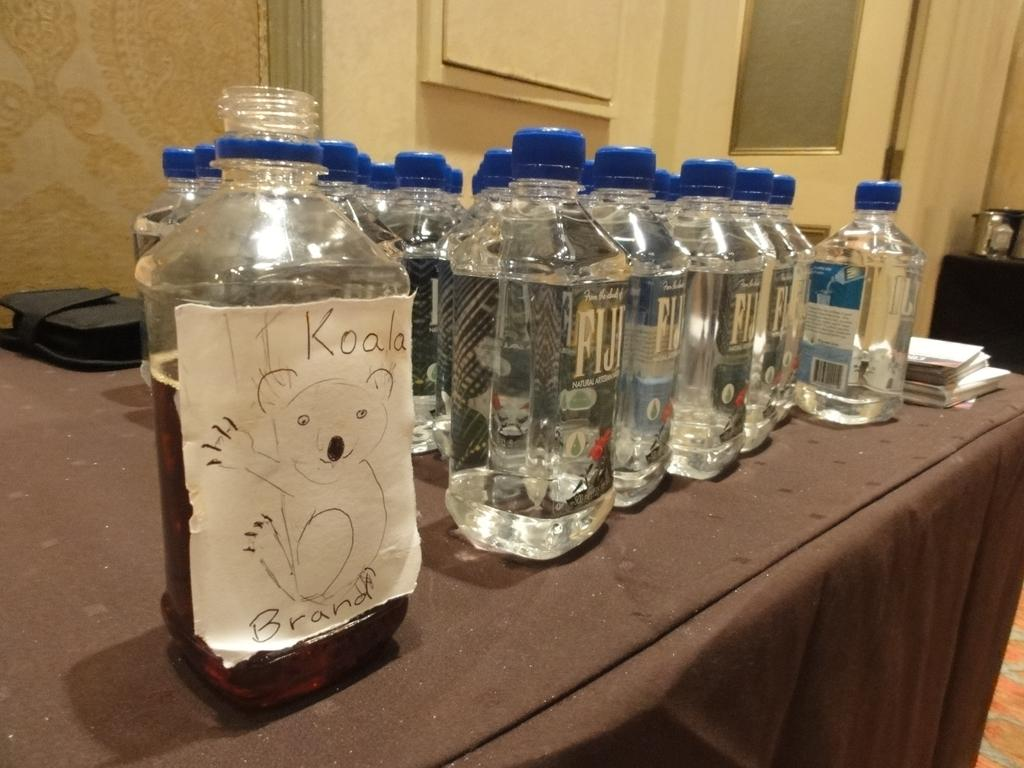<image>
Offer a succinct explanation of the picture presented. Bottle with a drawing and the words Koala on it next to some Fiji water. 